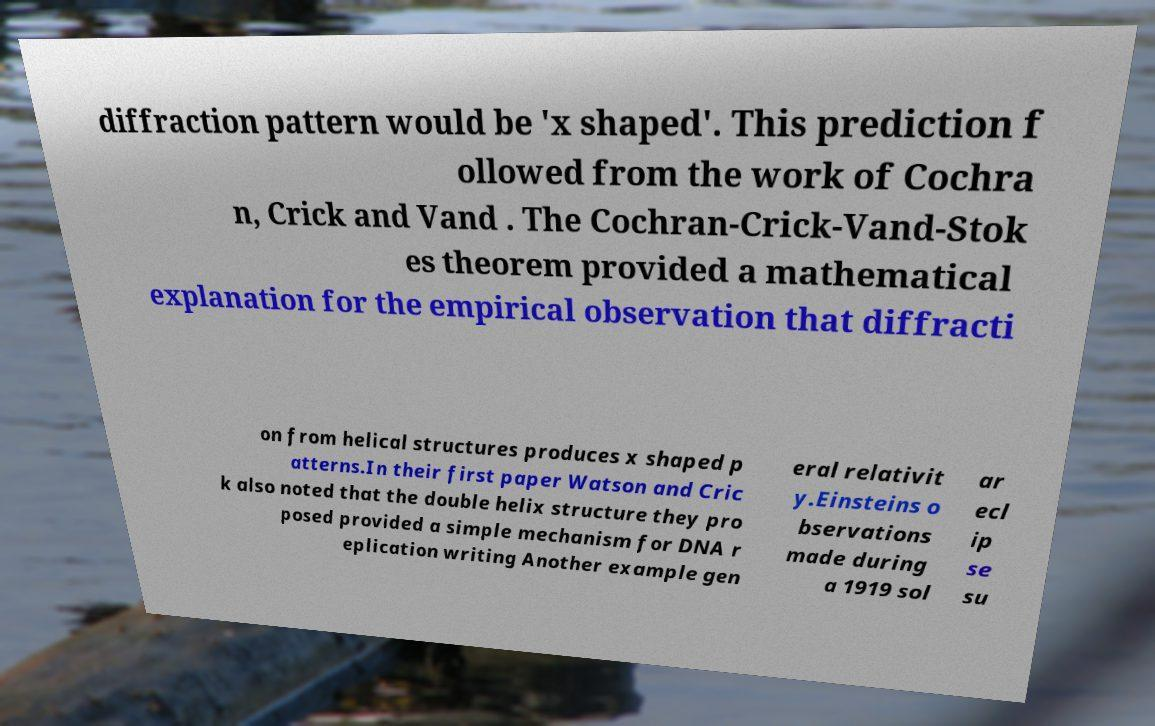For documentation purposes, I need the text within this image transcribed. Could you provide that? diffraction pattern would be 'x shaped'. This prediction f ollowed from the work of Cochra n, Crick and Vand . The Cochran-Crick-Vand-Stok es theorem provided a mathematical explanation for the empirical observation that diffracti on from helical structures produces x shaped p atterns.In their first paper Watson and Cric k also noted that the double helix structure they pro posed provided a simple mechanism for DNA r eplication writing Another example gen eral relativit y.Einsteins o bservations made during a 1919 sol ar ecl ip se su 